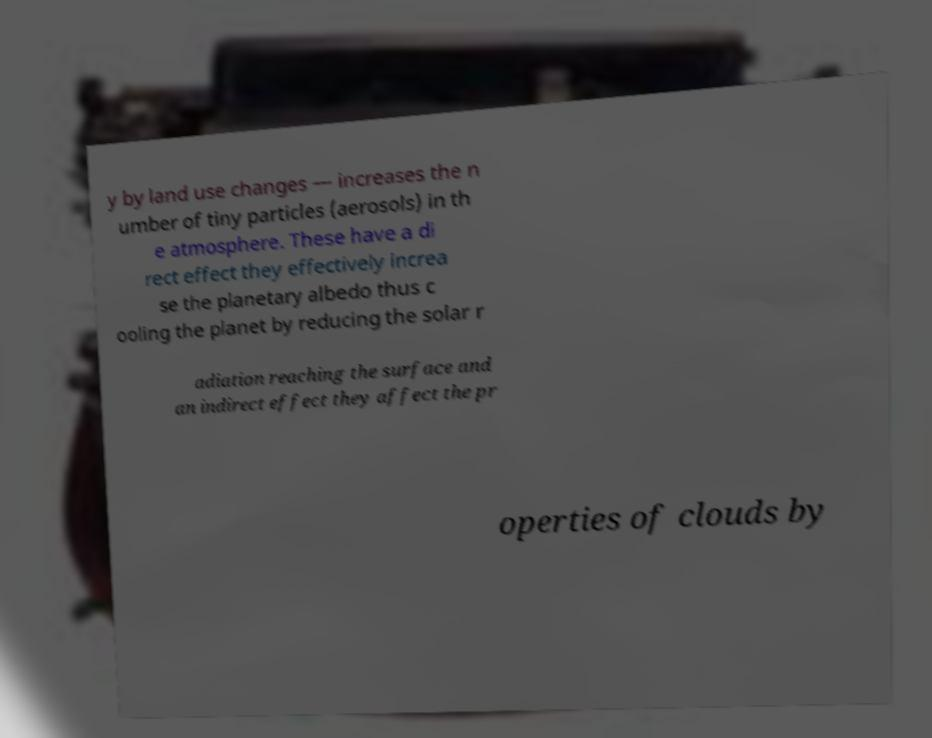There's text embedded in this image that I need extracted. Can you transcribe it verbatim? y by land use changes — increases the n umber of tiny particles (aerosols) in th e atmosphere. These have a di rect effect they effectively increa se the planetary albedo thus c ooling the planet by reducing the solar r adiation reaching the surface and an indirect effect they affect the pr operties of clouds by 